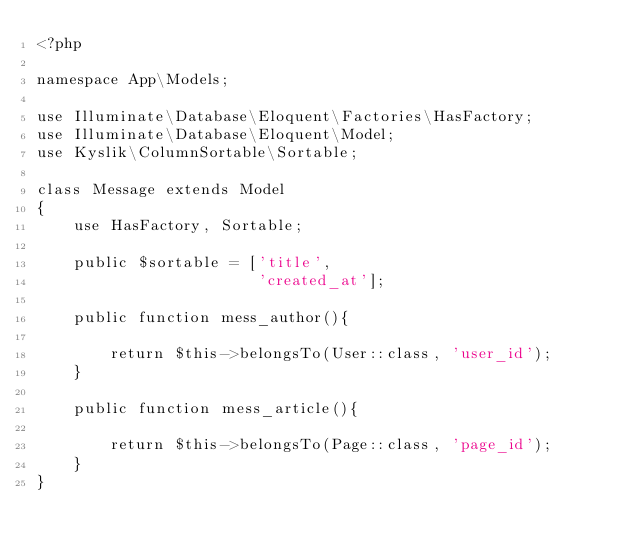<code> <loc_0><loc_0><loc_500><loc_500><_PHP_><?php

namespace App\Models;

use Illuminate\Database\Eloquent\Factories\HasFactory;
use Illuminate\Database\Eloquent\Model;
use Kyslik\ColumnSortable\Sortable;

class Message extends Model
{
    use HasFactory, Sortable;

    public $sortable = ['title',
                        'created_at'];

    public function mess_author(){

        return $this->belongsTo(User::class, 'user_id');
    }

    public function mess_article(){

        return $this->belongsTo(Page::class, 'page_id');
    }
}
</code> 